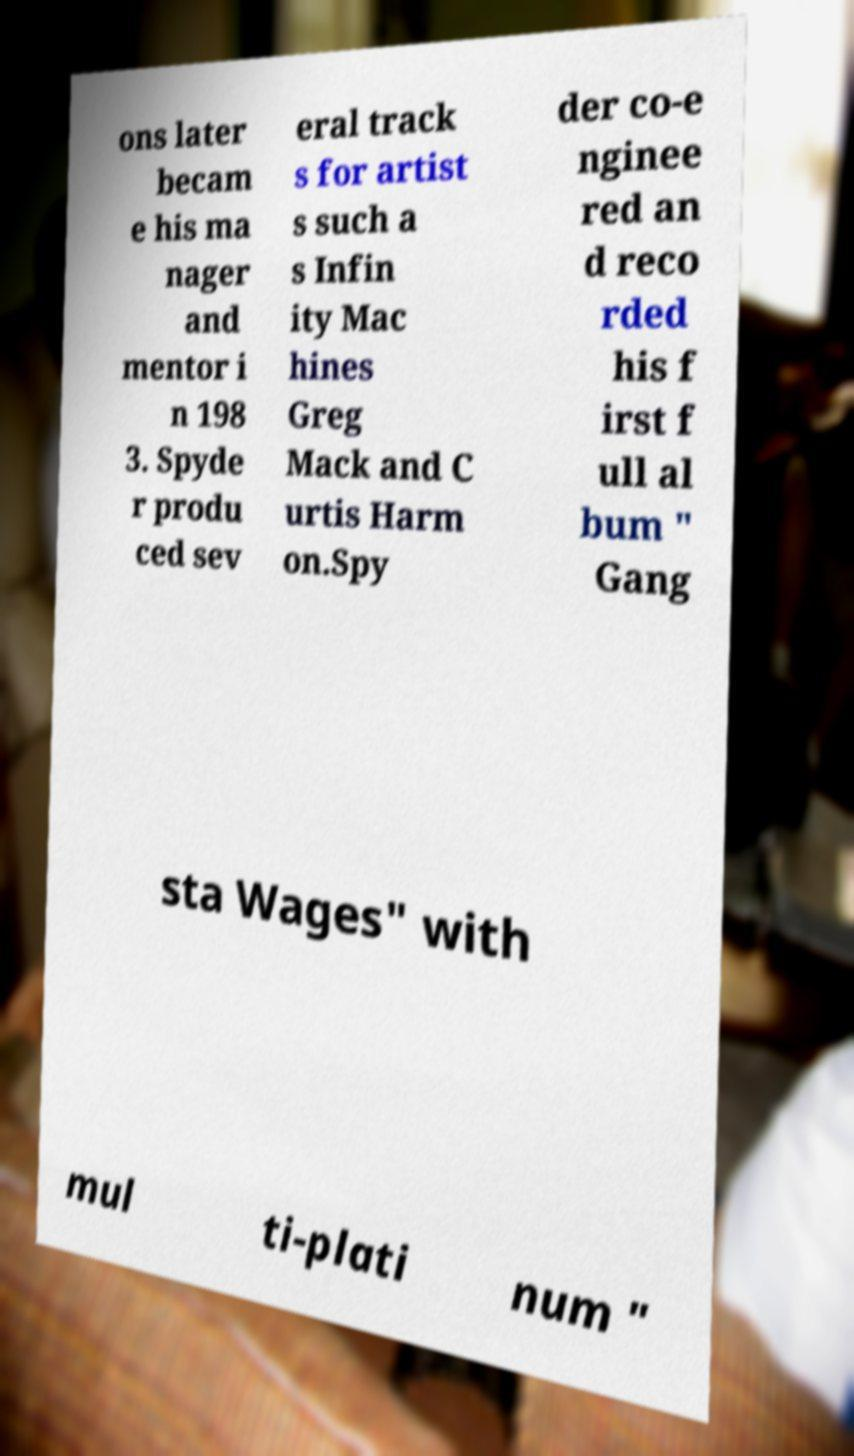Please identify and transcribe the text found in this image. ons later becam e his ma nager and mentor i n 198 3. Spyde r produ ced sev eral track s for artist s such a s Infin ity Mac hines Greg Mack and C urtis Harm on.Spy der co-e nginee red an d reco rded his f irst f ull al bum " Gang sta Wages" with mul ti-plati num " 